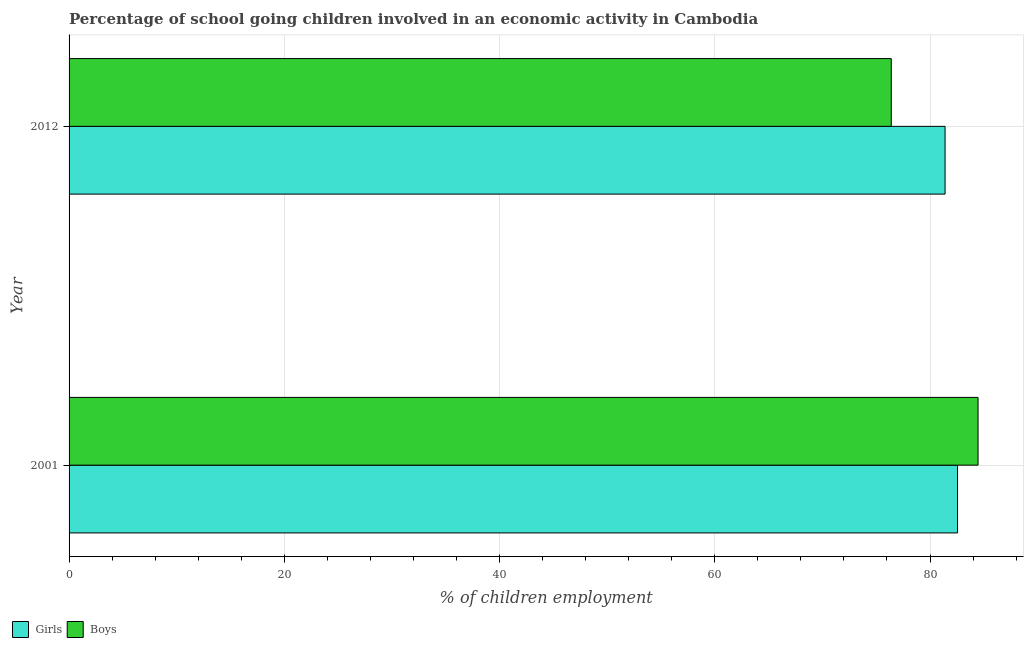How many different coloured bars are there?
Give a very brief answer. 2. How many groups of bars are there?
Keep it short and to the point. 2. Are the number of bars per tick equal to the number of legend labels?
Offer a terse response. Yes. In how many cases, is the number of bars for a given year not equal to the number of legend labels?
Your response must be concise. 0. What is the percentage of school going boys in 2001?
Your answer should be compact. 84.46. Across all years, what is the maximum percentage of school going girls?
Keep it short and to the point. 82.56. Across all years, what is the minimum percentage of school going girls?
Provide a short and direct response. 81.4. In which year was the percentage of school going boys maximum?
Your response must be concise. 2001. In which year was the percentage of school going girls minimum?
Provide a short and direct response. 2012. What is the total percentage of school going girls in the graph?
Ensure brevity in your answer.  163.96. What is the difference between the percentage of school going girls in 2001 and that in 2012?
Your answer should be very brief. 1.16. What is the difference between the percentage of school going girls in 2012 and the percentage of school going boys in 2001?
Offer a very short reply. -3.06. What is the average percentage of school going boys per year?
Provide a succinct answer. 80.43. In the year 2012, what is the difference between the percentage of school going girls and percentage of school going boys?
Provide a succinct answer. 5. Is the difference between the percentage of school going boys in 2001 and 2012 greater than the difference between the percentage of school going girls in 2001 and 2012?
Offer a terse response. Yes. In how many years, is the percentage of school going boys greater than the average percentage of school going boys taken over all years?
Your answer should be very brief. 1. What does the 2nd bar from the top in 2001 represents?
Give a very brief answer. Girls. What does the 1st bar from the bottom in 2012 represents?
Give a very brief answer. Girls. How many bars are there?
Provide a succinct answer. 4. Are all the bars in the graph horizontal?
Your answer should be compact. Yes. Are the values on the major ticks of X-axis written in scientific E-notation?
Your answer should be very brief. No. Does the graph contain any zero values?
Offer a very short reply. No. Does the graph contain grids?
Keep it short and to the point. Yes. How many legend labels are there?
Your answer should be very brief. 2. How are the legend labels stacked?
Ensure brevity in your answer.  Horizontal. What is the title of the graph?
Offer a terse response. Percentage of school going children involved in an economic activity in Cambodia. Does "Investment in Telecom" appear as one of the legend labels in the graph?
Offer a very short reply. No. What is the label or title of the X-axis?
Give a very brief answer. % of children employment. What is the % of children employment in Girls in 2001?
Your answer should be very brief. 82.56. What is the % of children employment of Boys in 2001?
Provide a succinct answer. 84.46. What is the % of children employment in Girls in 2012?
Ensure brevity in your answer.  81.4. What is the % of children employment in Boys in 2012?
Provide a short and direct response. 76.4. Across all years, what is the maximum % of children employment in Girls?
Keep it short and to the point. 82.56. Across all years, what is the maximum % of children employment in Boys?
Your answer should be very brief. 84.46. Across all years, what is the minimum % of children employment in Girls?
Your answer should be very brief. 81.4. Across all years, what is the minimum % of children employment in Boys?
Make the answer very short. 76.4. What is the total % of children employment in Girls in the graph?
Ensure brevity in your answer.  163.96. What is the total % of children employment in Boys in the graph?
Your answer should be compact. 160.86. What is the difference between the % of children employment of Girls in 2001 and that in 2012?
Make the answer very short. 1.16. What is the difference between the % of children employment of Boys in 2001 and that in 2012?
Your answer should be very brief. 8.06. What is the difference between the % of children employment of Girls in 2001 and the % of children employment of Boys in 2012?
Provide a succinct answer. 6.16. What is the average % of children employment in Girls per year?
Ensure brevity in your answer.  81.98. What is the average % of children employment in Boys per year?
Keep it short and to the point. 80.43. In the year 2001, what is the difference between the % of children employment of Girls and % of children employment of Boys?
Keep it short and to the point. -1.91. In the year 2012, what is the difference between the % of children employment in Girls and % of children employment in Boys?
Provide a short and direct response. 5. What is the ratio of the % of children employment of Girls in 2001 to that in 2012?
Provide a succinct answer. 1.01. What is the ratio of the % of children employment in Boys in 2001 to that in 2012?
Ensure brevity in your answer.  1.11. What is the difference between the highest and the second highest % of children employment in Girls?
Provide a succinct answer. 1.16. What is the difference between the highest and the second highest % of children employment in Boys?
Ensure brevity in your answer.  8.06. What is the difference between the highest and the lowest % of children employment of Girls?
Provide a short and direct response. 1.16. What is the difference between the highest and the lowest % of children employment of Boys?
Keep it short and to the point. 8.06. 